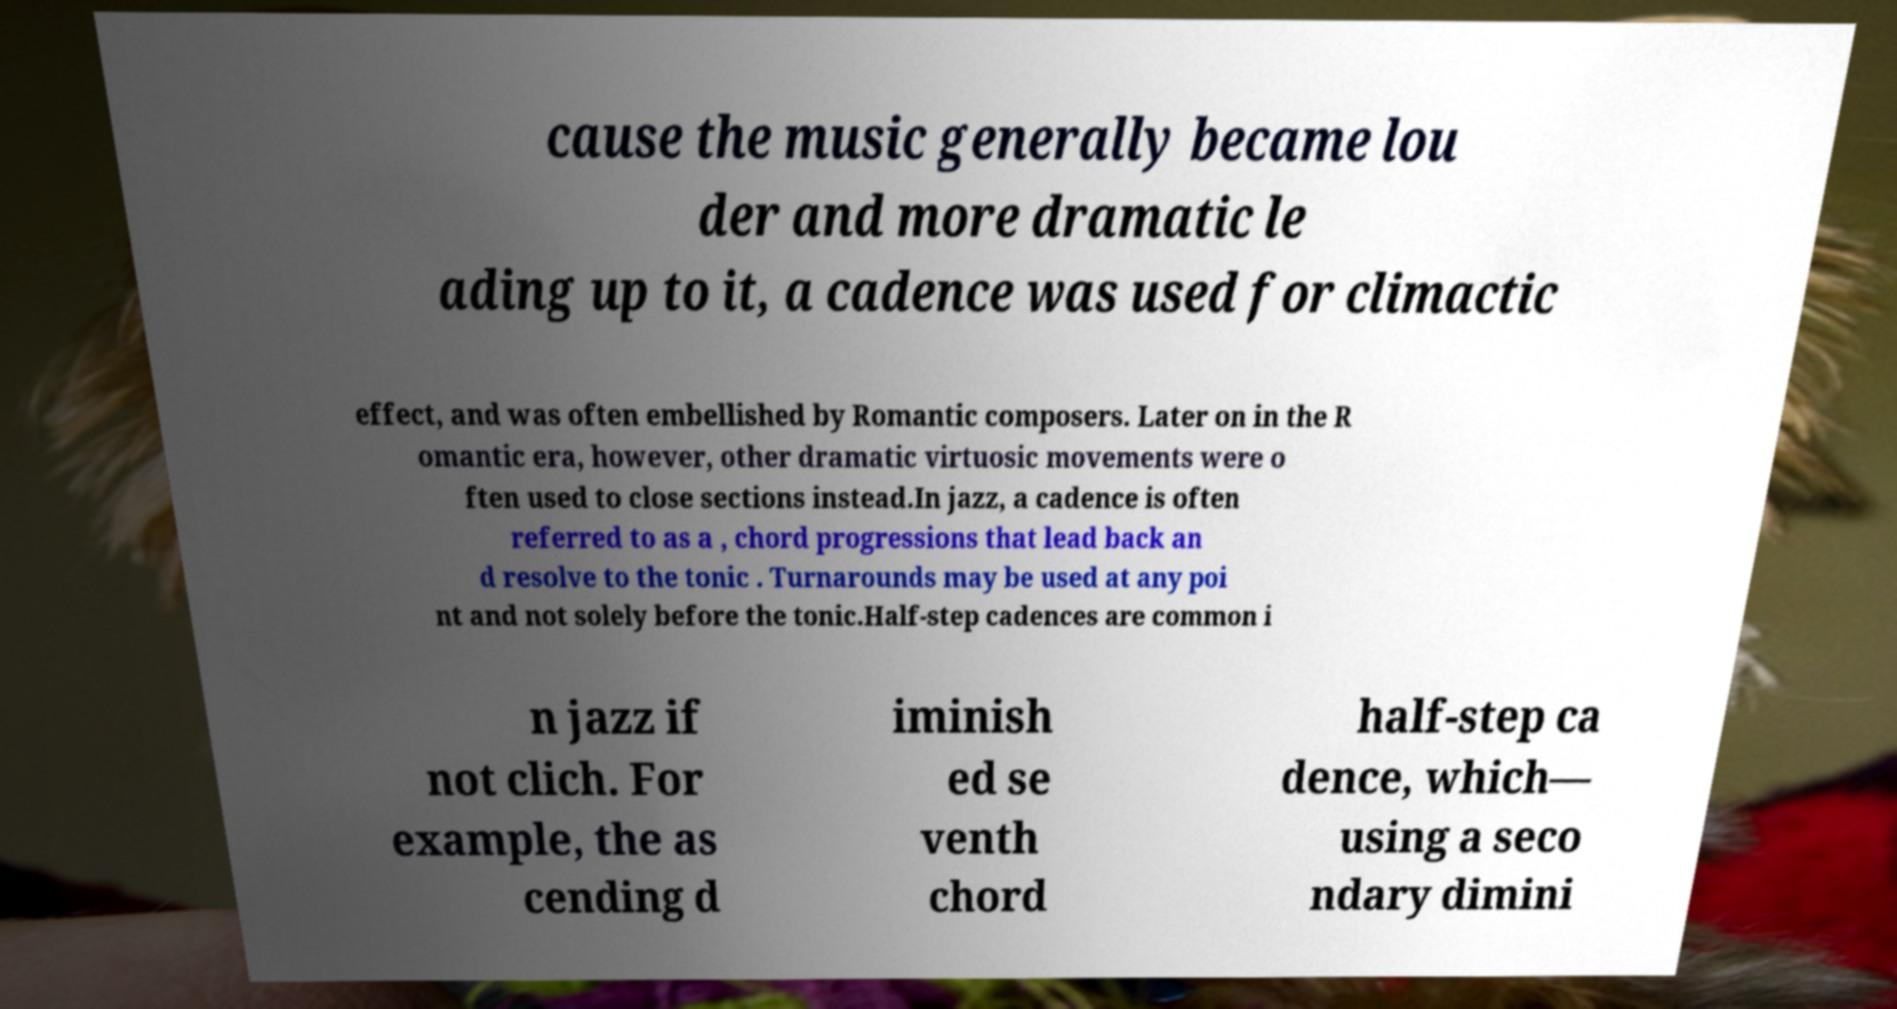Can you read and provide the text displayed in the image?This photo seems to have some interesting text. Can you extract and type it out for me? cause the music generally became lou der and more dramatic le ading up to it, a cadence was used for climactic effect, and was often embellished by Romantic composers. Later on in the R omantic era, however, other dramatic virtuosic movements were o ften used to close sections instead.In jazz, a cadence is often referred to as a , chord progressions that lead back an d resolve to the tonic . Turnarounds may be used at any poi nt and not solely before the tonic.Half-step cadences are common i n jazz if not clich. For example, the as cending d iminish ed se venth chord half-step ca dence, which— using a seco ndary dimini 